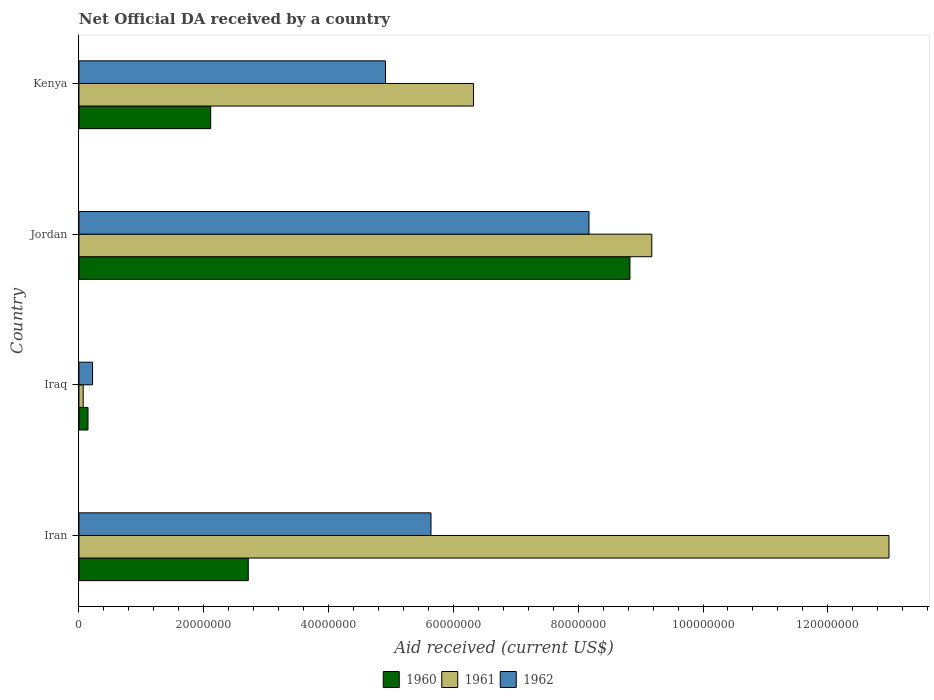How many different coloured bars are there?
Offer a terse response. 3. How many groups of bars are there?
Provide a succinct answer. 4. What is the label of the 3rd group of bars from the top?
Provide a short and direct response. Iraq. What is the net official development assistance aid received in 1961 in Iraq?
Provide a short and direct response. 6.80e+05. Across all countries, what is the maximum net official development assistance aid received in 1961?
Ensure brevity in your answer.  1.30e+08. Across all countries, what is the minimum net official development assistance aid received in 1962?
Make the answer very short. 2.18e+06. In which country was the net official development assistance aid received in 1960 maximum?
Offer a terse response. Jordan. In which country was the net official development assistance aid received in 1961 minimum?
Provide a short and direct response. Iraq. What is the total net official development assistance aid received in 1961 in the graph?
Keep it short and to the point. 2.86e+08. What is the difference between the net official development assistance aid received in 1960 in Iraq and that in Jordan?
Make the answer very short. -8.68e+07. What is the difference between the net official development assistance aid received in 1961 in Jordan and the net official development assistance aid received in 1962 in Iran?
Your answer should be compact. 3.54e+07. What is the average net official development assistance aid received in 1962 per country?
Your answer should be compact. 4.74e+07. What is the difference between the net official development assistance aid received in 1962 and net official development assistance aid received in 1961 in Iraq?
Offer a terse response. 1.50e+06. What is the ratio of the net official development assistance aid received in 1960 in Jordan to that in Kenya?
Make the answer very short. 4.18. Is the difference between the net official development assistance aid received in 1962 in Iran and Jordan greater than the difference between the net official development assistance aid received in 1961 in Iran and Jordan?
Give a very brief answer. No. What is the difference between the highest and the second highest net official development assistance aid received in 1962?
Your response must be concise. 2.53e+07. What is the difference between the highest and the lowest net official development assistance aid received in 1960?
Keep it short and to the point. 8.68e+07. What does the 2nd bar from the top in Jordan represents?
Provide a short and direct response. 1961. What does the 3rd bar from the bottom in Jordan represents?
Give a very brief answer. 1962. Are all the bars in the graph horizontal?
Offer a very short reply. Yes. How many countries are there in the graph?
Your answer should be very brief. 4. What is the difference between two consecutive major ticks on the X-axis?
Offer a terse response. 2.00e+07. Are the values on the major ticks of X-axis written in scientific E-notation?
Your answer should be very brief. No. Does the graph contain grids?
Give a very brief answer. No. Where does the legend appear in the graph?
Keep it short and to the point. Bottom center. What is the title of the graph?
Ensure brevity in your answer.  Net Official DA received by a country. Does "1973" appear as one of the legend labels in the graph?
Offer a very short reply. No. What is the label or title of the X-axis?
Offer a terse response. Aid received (current US$). What is the label or title of the Y-axis?
Your answer should be very brief. Country. What is the Aid received (current US$) in 1960 in Iran?
Your answer should be compact. 2.71e+07. What is the Aid received (current US$) in 1961 in Iran?
Offer a terse response. 1.30e+08. What is the Aid received (current US$) in 1962 in Iran?
Keep it short and to the point. 5.64e+07. What is the Aid received (current US$) in 1960 in Iraq?
Offer a terse response. 1.45e+06. What is the Aid received (current US$) in 1961 in Iraq?
Offer a terse response. 6.80e+05. What is the Aid received (current US$) of 1962 in Iraq?
Offer a very short reply. 2.18e+06. What is the Aid received (current US$) in 1960 in Jordan?
Provide a succinct answer. 8.83e+07. What is the Aid received (current US$) of 1961 in Jordan?
Provide a short and direct response. 9.18e+07. What is the Aid received (current US$) of 1962 in Jordan?
Offer a terse response. 8.17e+07. What is the Aid received (current US$) of 1960 in Kenya?
Your answer should be very brief. 2.11e+07. What is the Aid received (current US$) of 1961 in Kenya?
Give a very brief answer. 6.32e+07. What is the Aid received (current US$) in 1962 in Kenya?
Give a very brief answer. 4.91e+07. Across all countries, what is the maximum Aid received (current US$) in 1960?
Your answer should be very brief. 8.83e+07. Across all countries, what is the maximum Aid received (current US$) of 1961?
Ensure brevity in your answer.  1.30e+08. Across all countries, what is the maximum Aid received (current US$) in 1962?
Provide a short and direct response. 8.17e+07. Across all countries, what is the minimum Aid received (current US$) of 1960?
Provide a succinct answer. 1.45e+06. Across all countries, what is the minimum Aid received (current US$) of 1961?
Make the answer very short. 6.80e+05. Across all countries, what is the minimum Aid received (current US$) in 1962?
Ensure brevity in your answer.  2.18e+06. What is the total Aid received (current US$) of 1960 in the graph?
Provide a short and direct response. 1.38e+08. What is the total Aid received (current US$) in 1961 in the graph?
Offer a terse response. 2.86e+08. What is the total Aid received (current US$) in 1962 in the graph?
Provide a succinct answer. 1.89e+08. What is the difference between the Aid received (current US$) in 1960 in Iran and that in Iraq?
Your answer should be compact. 2.57e+07. What is the difference between the Aid received (current US$) in 1961 in Iran and that in Iraq?
Provide a succinct answer. 1.29e+08. What is the difference between the Aid received (current US$) of 1962 in Iran and that in Iraq?
Your response must be concise. 5.42e+07. What is the difference between the Aid received (current US$) of 1960 in Iran and that in Jordan?
Keep it short and to the point. -6.12e+07. What is the difference between the Aid received (current US$) of 1961 in Iran and that in Jordan?
Your response must be concise. 3.80e+07. What is the difference between the Aid received (current US$) of 1962 in Iran and that in Jordan?
Your answer should be very brief. -2.53e+07. What is the difference between the Aid received (current US$) of 1960 in Iran and that in Kenya?
Offer a very short reply. 6.02e+06. What is the difference between the Aid received (current US$) of 1961 in Iran and that in Kenya?
Provide a short and direct response. 6.66e+07. What is the difference between the Aid received (current US$) in 1962 in Iran and that in Kenya?
Your answer should be very brief. 7.29e+06. What is the difference between the Aid received (current US$) of 1960 in Iraq and that in Jordan?
Offer a terse response. -8.68e+07. What is the difference between the Aid received (current US$) of 1961 in Iraq and that in Jordan?
Your answer should be very brief. -9.11e+07. What is the difference between the Aid received (current US$) in 1962 in Iraq and that in Jordan?
Ensure brevity in your answer.  -7.96e+07. What is the difference between the Aid received (current US$) in 1960 in Iraq and that in Kenya?
Your response must be concise. -1.97e+07. What is the difference between the Aid received (current US$) of 1961 in Iraq and that in Kenya?
Provide a short and direct response. -6.26e+07. What is the difference between the Aid received (current US$) of 1962 in Iraq and that in Kenya?
Offer a very short reply. -4.69e+07. What is the difference between the Aid received (current US$) in 1960 in Jordan and that in Kenya?
Your answer should be very brief. 6.72e+07. What is the difference between the Aid received (current US$) of 1961 in Jordan and that in Kenya?
Your response must be concise. 2.86e+07. What is the difference between the Aid received (current US$) in 1962 in Jordan and that in Kenya?
Ensure brevity in your answer.  3.26e+07. What is the difference between the Aid received (current US$) in 1960 in Iran and the Aid received (current US$) in 1961 in Iraq?
Offer a terse response. 2.64e+07. What is the difference between the Aid received (current US$) in 1960 in Iran and the Aid received (current US$) in 1962 in Iraq?
Offer a very short reply. 2.50e+07. What is the difference between the Aid received (current US$) in 1961 in Iran and the Aid received (current US$) in 1962 in Iraq?
Offer a terse response. 1.28e+08. What is the difference between the Aid received (current US$) of 1960 in Iran and the Aid received (current US$) of 1961 in Jordan?
Offer a terse response. -6.47e+07. What is the difference between the Aid received (current US$) in 1960 in Iran and the Aid received (current US$) in 1962 in Jordan?
Give a very brief answer. -5.46e+07. What is the difference between the Aid received (current US$) in 1961 in Iran and the Aid received (current US$) in 1962 in Jordan?
Provide a succinct answer. 4.81e+07. What is the difference between the Aid received (current US$) of 1960 in Iran and the Aid received (current US$) of 1961 in Kenya?
Your answer should be compact. -3.61e+07. What is the difference between the Aid received (current US$) in 1960 in Iran and the Aid received (current US$) in 1962 in Kenya?
Ensure brevity in your answer.  -2.20e+07. What is the difference between the Aid received (current US$) in 1961 in Iran and the Aid received (current US$) in 1962 in Kenya?
Ensure brevity in your answer.  8.07e+07. What is the difference between the Aid received (current US$) in 1960 in Iraq and the Aid received (current US$) in 1961 in Jordan?
Make the answer very short. -9.03e+07. What is the difference between the Aid received (current US$) of 1960 in Iraq and the Aid received (current US$) of 1962 in Jordan?
Provide a succinct answer. -8.03e+07. What is the difference between the Aid received (current US$) in 1961 in Iraq and the Aid received (current US$) in 1962 in Jordan?
Offer a very short reply. -8.10e+07. What is the difference between the Aid received (current US$) in 1960 in Iraq and the Aid received (current US$) in 1961 in Kenya?
Your response must be concise. -6.18e+07. What is the difference between the Aid received (current US$) in 1960 in Iraq and the Aid received (current US$) in 1962 in Kenya?
Offer a very short reply. -4.77e+07. What is the difference between the Aid received (current US$) in 1961 in Iraq and the Aid received (current US$) in 1962 in Kenya?
Your response must be concise. -4.84e+07. What is the difference between the Aid received (current US$) in 1960 in Jordan and the Aid received (current US$) in 1961 in Kenya?
Offer a terse response. 2.51e+07. What is the difference between the Aid received (current US$) of 1960 in Jordan and the Aid received (current US$) of 1962 in Kenya?
Give a very brief answer. 3.92e+07. What is the difference between the Aid received (current US$) in 1961 in Jordan and the Aid received (current US$) in 1962 in Kenya?
Provide a succinct answer. 4.27e+07. What is the average Aid received (current US$) in 1960 per country?
Make the answer very short. 3.45e+07. What is the average Aid received (current US$) in 1961 per country?
Provide a succinct answer. 7.14e+07. What is the average Aid received (current US$) of 1962 per country?
Provide a short and direct response. 4.74e+07. What is the difference between the Aid received (current US$) of 1960 and Aid received (current US$) of 1961 in Iran?
Give a very brief answer. -1.03e+08. What is the difference between the Aid received (current US$) of 1960 and Aid received (current US$) of 1962 in Iran?
Provide a succinct answer. -2.93e+07. What is the difference between the Aid received (current US$) of 1961 and Aid received (current US$) of 1962 in Iran?
Make the answer very short. 7.34e+07. What is the difference between the Aid received (current US$) in 1960 and Aid received (current US$) in 1961 in Iraq?
Your answer should be compact. 7.70e+05. What is the difference between the Aid received (current US$) in 1960 and Aid received (current US$) in 1962 in Iraq?
Offer a terse response. -7.30e+05. What is the difference between the Aid received (current US$) in 1961 and Aid received (current US$) in 1962 in Iraq?
Offer a very short reply. -1.50e+06. What is the difference between the Aid received (current US$) in 1960 and Aid received (current US$) in 1961 in Jordan?
Your answer should be compact. -3.50e+06. What is the difference between the Aid received (current US$) of 1960 and Aid received (current US$) of 1962 in Jordan?
Ensure brevity in your answer.  6.56e+06. What is the difference between the Aid received (current US$) in 1961 and Aid received (current US$) in 1962 in Jordan?
Offer a terse response. 1.01e+07. What is the difference between the Aid received (current US$) in 1960 and Aid received (current US$) in 1961 in Kenya?
Offer a terse response. -4.21e+07. What is the difference between the Aid received (current US$) in 1960 and Aid received (current US$) in 1962 in Kenya?
Your answer should be very brief. -2.80e+07. What is the difference between the Aid received (current US$) in 1961 and Aid received (current US$) in 1962 in Kenya?
Make the answer very short. 1.41e+07. What is the ratio of the Aid received (current US$) of 1960 in Iran to that in Iraq?
Offer a very short reply. 18.71. What is the ratio of the Aid received (current US$) of 1961 in Iran to that in Iraq?
Provide a succinct answer. 190.88. What is the ratio of the Aid received (current US$) in 1962 in Iran to that in Iraq?
Keep it short and to the point. 25.88. What is the ratio of the Aid received (current US$) in 1960 in Iran to that in Jordan?
Provide a short and direct response. 0.31. What is the ratio of the Aid received (current US$) in 1961 in Iran to that in Jordan?
Offer a very short reply. 1.41. What is the ratio of the Aid received (current US$) in 1962 in Iran to that in Jordan?
Make the answer very short. 0.69. What is the ratio of the Aid received (current US$) of 1960 in Iran to that in Kenya?
Ensure brevity in your answer.  1.29. What is the ratio of the Aid received (current US$) in 1961 in Iran to that in Kenya?
Your answer should be very brief. 2.05. What is the ratio of the Aid received (current US$) in 1962 in Iran to that in Kenya?
Your response must be concise. 1.15. What is the ratio of the Aid received (current US$) in 1960 in Iraq to that in Jordan?
Ensure brevity in your answer.  0.02. What is the ratio of the Aid received (current US$) in 1961 in Iraq to that in Jordan?
Offer a very short reply. 0.01. What is the ratio of the Aid received (current US$) in 1962 in Iraq to that in Jordan?
Provide a short and direct response. 0.03. What is the ratio of the Aid received (current US$) of 1960 in Iraq to that in Kenya?
Provide a short and direct response. 0.07. What is the ratio of the Aid received (current US$) of 1961 in Iraq to that in Kenya?
Your answer should be very brief. 0.01. What is the ratio of the Aid received (current US$) of 1962 in Iraq to that in Kenya?
Make the answer very short. 0.04. What is the ratio of the Aid received (current US$) in 1960 in Jordan to that in Kenya?
Your answer should be compact. 4.18. What is the ratio of the Aid received (current US$) of 1961 in Jordan to that in Kenya?
Make the answer very short. 1.45. What is the ratio of the Aid received (current US$) in 1962 in Jordan to that in Kenya?
Keep it short and to the point. 1.66. What is the difference between the highest and the second highest Aid received (current US$) in 1960?
Offer a terse response. 6.12e+07. What is the difference between the highest and the second highest Aid received (current US$) in 1961?
Your answer should be compact. 3.80e+07. What is the difference between the highest and the second highest Aid received (current US$) in 1962?
Keep it short and to the point. 2.53e+07. What is the difference between the highest and the lowest Aid received (current US$) in 1960?
Give a very brief answer. 8.68e+07. What is the difference between the highest and the lowest Aid received (current US$) in 1961?
Offer a very short reply. 1.29e+08. What is the difference between the highest and the lowest Aid received (current US$) in 1962?
Ensure brevity in your answer.  7.96e+07. 